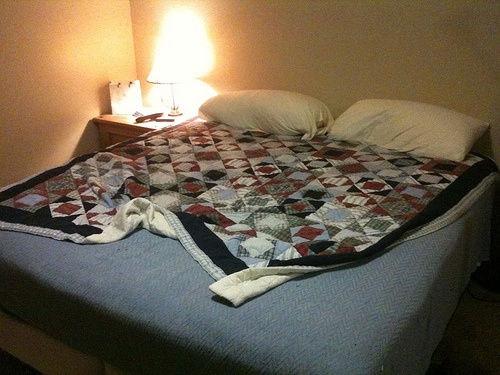Describe the objects in this image and their specific colors. I can see a bed in olive, black, gray, tan, and darkgray tones in this image. 